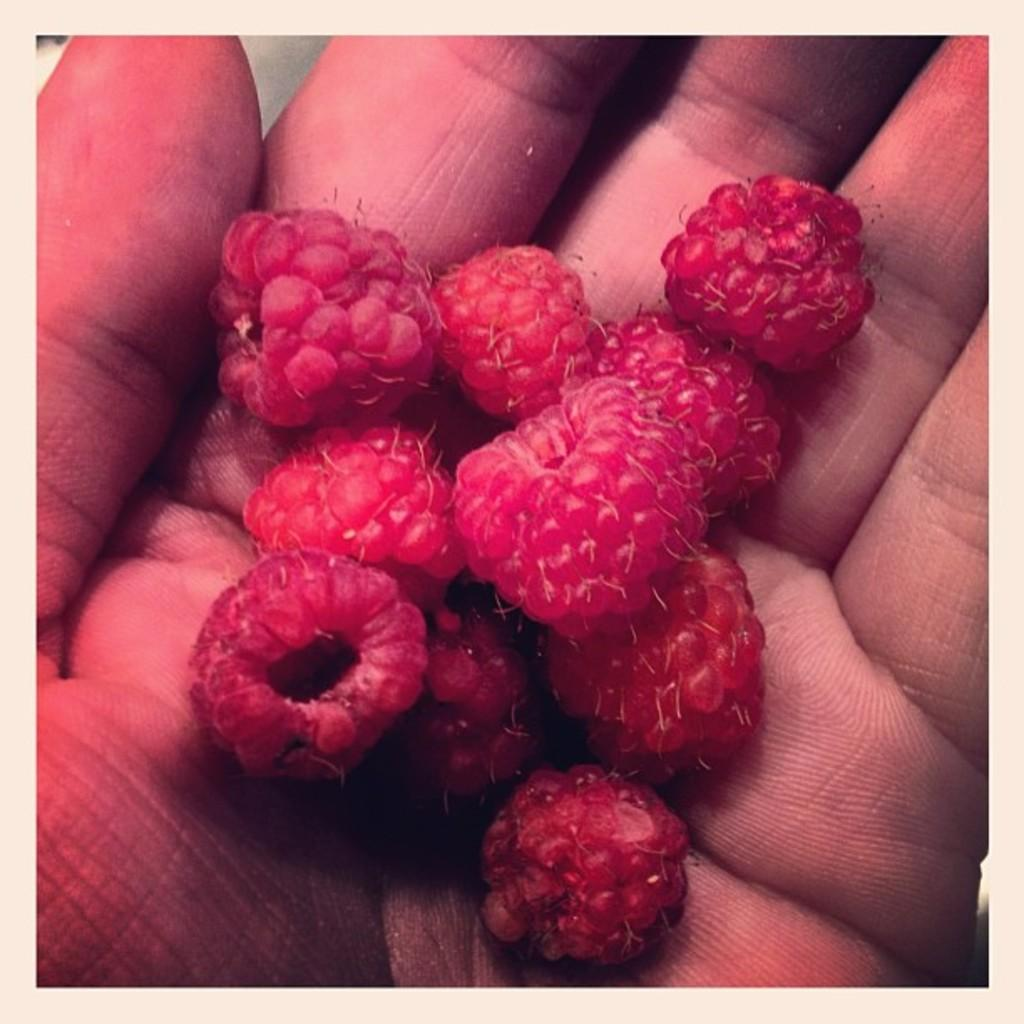What is being held in the hand in the image? There are raspberries on a hand in the image. Can you describe the raspberries in the image? The raspberries appear to be fresh and red. How many raspberries can be seen on the hand? It is difficult to determine the exact number of raspberries from the image, but there are several raspberries visible. What type of verse is being recited by the flowers in the image? There are no flowers or any recitation of verses present in the image; it features raspberries on a hand. Can you describe the insect that is interacting with the raspberries in the image? There is no insect present in the image; it only shows raspberries on a hand. 